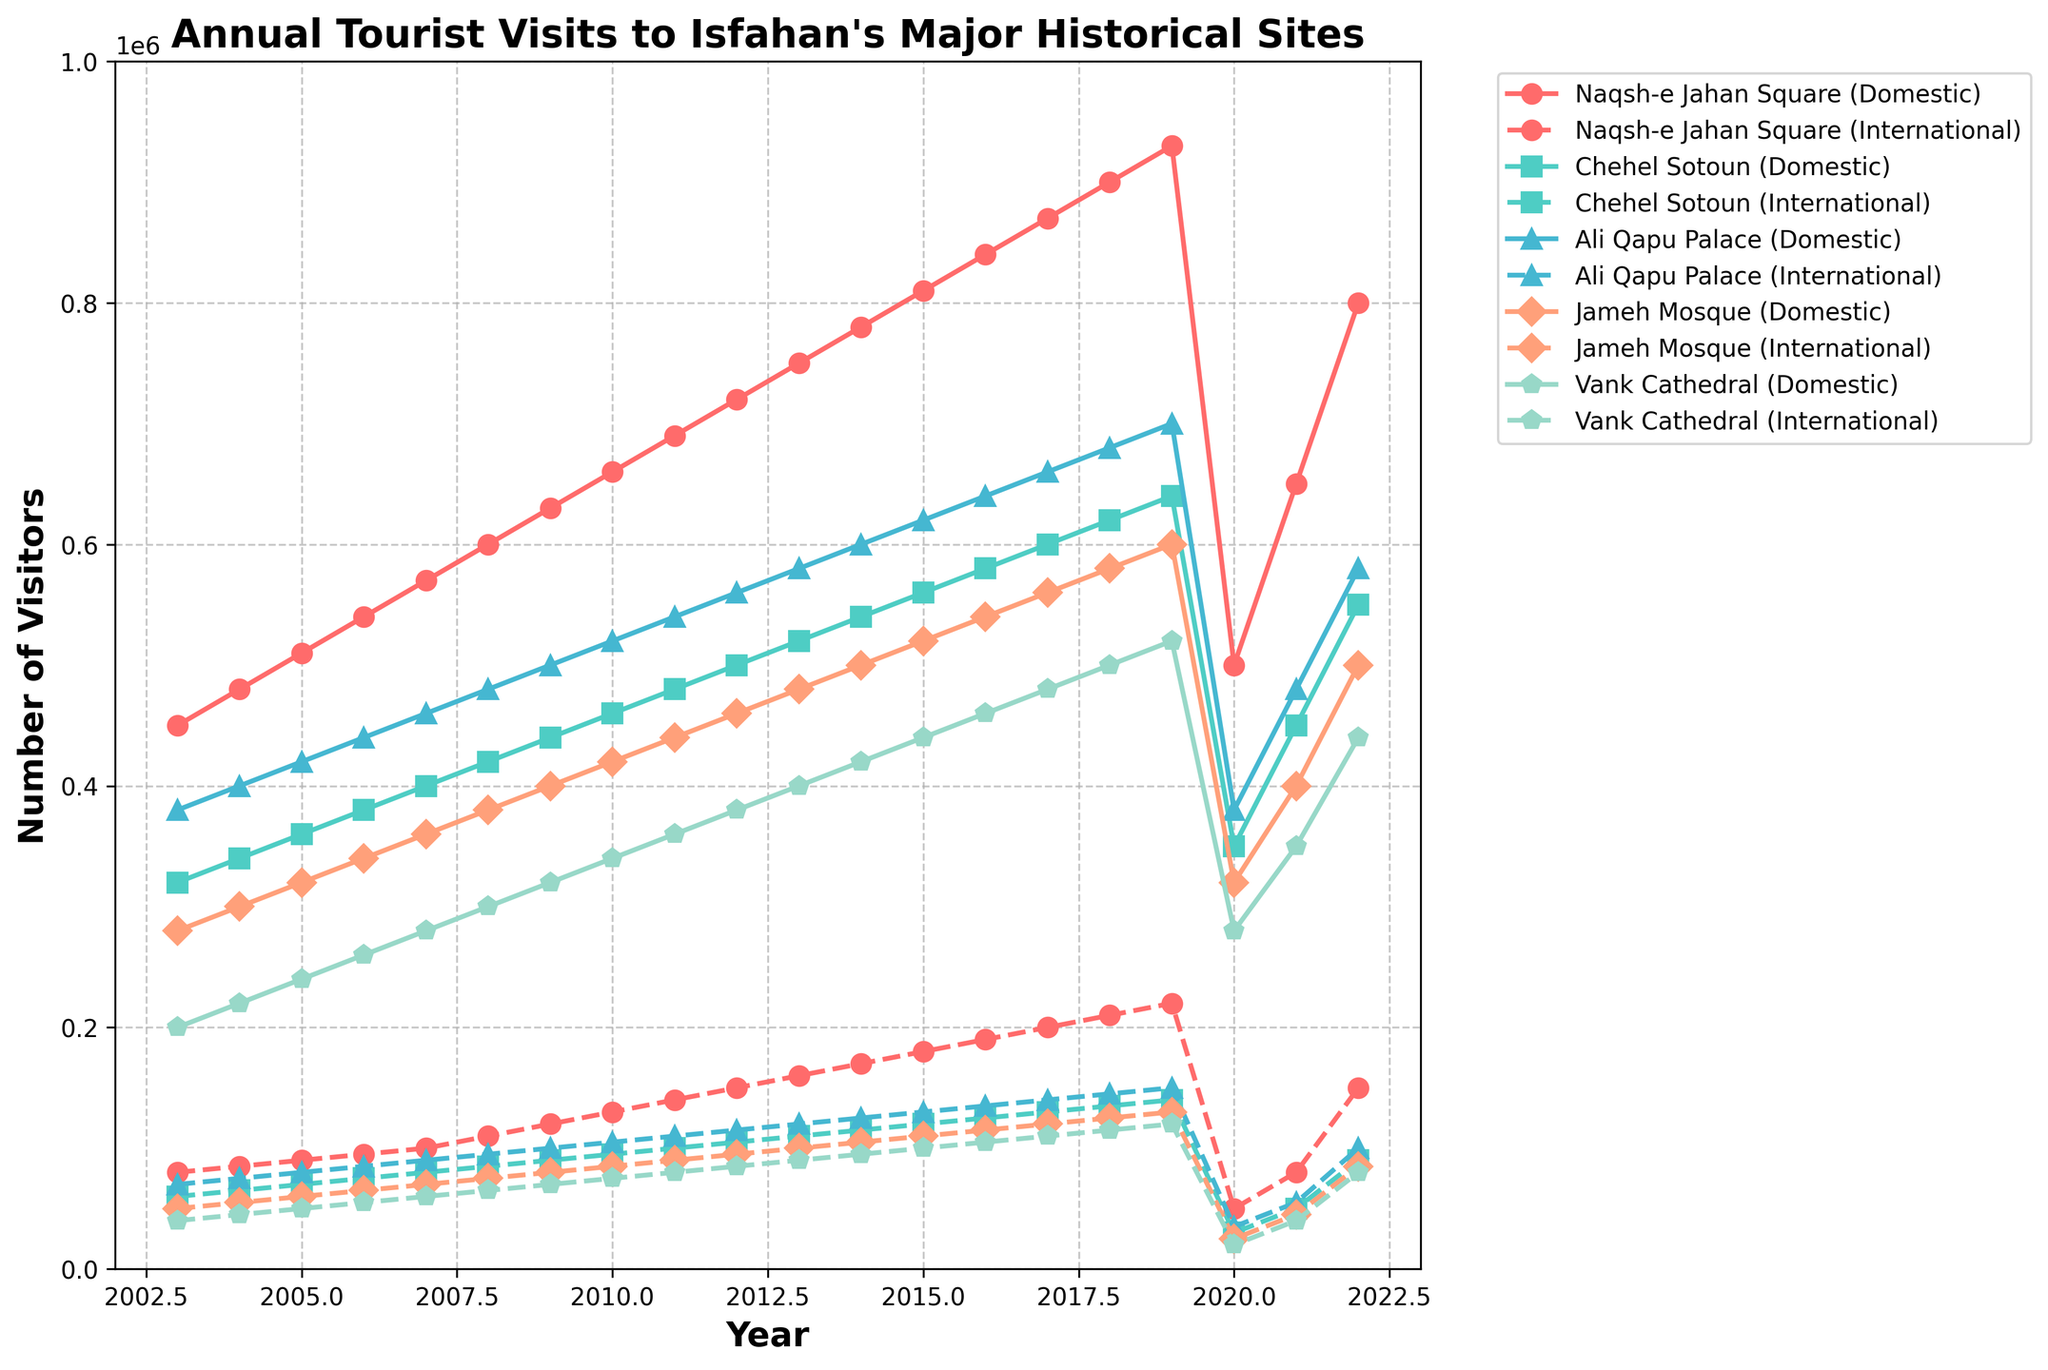What was the total number of domestic visitors to Naqsh-e Jahan Square and Chehel Sotoun in 2017? To find the total, add the number of domestic visitors to Naqsh-e Jahan Square and Chehel Sotoun in 2017. From the chart, Naqsh-e Jahan Square (Domestic) has 870,000 visitors and Chehel Sotoun (Domestic) has 600,000 visitors. The total is 870,000 + 600,000 = 1,470,000
Answer: 1,470,000 Which site had the highest number of international visitors in 2022? From the chart, comparing the values for international visitors across all sites in 2022: Naqsh-e Jahan Square - 150,000; Chehel Sotoun - 90,000; Ali Qapu Palace - 100,000; Jameh Mosque - 85,000; Vank Cathedral - 80,000. Naqsh-e Jahan Square has the highest number of international visitors with 150,000.
Answer: Naqsh-e Jahan Square By how much did the number of domestic visitors to Ali Qapu Palace increase from 2005 to 2019? From the chart, the number of domestic visitors to Ali Qapu Palace in 2005 was 420,000 and in 2019 it was 700,000. The increase is calculated by subtracting the 2005 figure from the 2019 figure: 700,000 - 420,000 = 280,000
Answer: 280,000 In which year did the Jameh Mosque (Domestic) first surpass 500,000 visitors? From the chart, scanning the figures for Jameh Mosque (Domestic), in 2014 it had 500,000 visitors for the first time.
Answer: 2014 What is the average number of international visitors to Vank Cathedral between 2003 and 2009? To find the average, sum the number of international visitors to Vank Cathedral from each specified year and divide by the number of years: (40,000 + 45,000 + 50,000 + 55,000 + 60,000 + 65,000 + 70,000) / 7 = 385,000 / 7 ≈ 55,000
Answer: 55,000 How did the number of international visitors to Naqsh-e Jahan Square change from 2019 to 2020? From the chart, the number of international visitors to Naqsh-e Jahan Square fell from 220,000 in 2019 to 50,000 in 2020. The change can be calculated by subtracting the 2020 figure from the 2019 figure: 220,000 - 50,000 = 170,000. There was a decrease of 170,000 visitors.
Answer: Decrease by 170,000 Which site had almost equal numbers of domestic and international visitors in 2020? From the chart, all sites show much lower numbers in 2020 due to special contexts, but Vank Cathedral had 280,000 domestic visitors and 20,000 international visitors with the smallest gap closer to this comparison.
Answer: Vank Cathedral What were the figures of domestic and international visitors in 2003 and 2020 for Naqsh-e Jahan Square? Referring to the chart, in 2003, Naqsh-e Jahan Square had 450,000 domestic and 80,000 international visitors. In 2020, due to the pandemic, it dropped to 500,000 domestic and 50,000 international visitors.
Answer: 450,000 (Domestic), 80,000 (International) in 2003; 500,000 (Domestic), 50,000 (International) in 2020 What is the trend for the number of international visitors to Chehel Sotoun from 2018 to 2022? From the chart, the trend for international visitors to Chehel Sotoun shows a rise initially from 135,000 in 2018 to 140,000 in 2019, then a sharp drop to 30,000 in 2020, followed by an increase to 50,000 in 2021, reaching 90,000 in 2022. This depicts a fall in 2020 due to known global events and a steady recovery onwards.
Answer: Rise initially, sharp drop in 2020, steady recovery How do the domestic visitor figures of Naqsh-e Jahan Square compare between the years 2006 and 2022? From the chart, in 2006, Naqsh-e Jahan Square had 540,000 domestic visitors, and in 2022, it had 800,000 domestic visitors. Comparing these figures shows an increase of 260,000 visitors in 2022 compared to 2006.
Answer: Increase by 260,000 